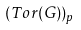<formula> <loc_0><loc_0><loc_500><loc_500>( T o r ( G ) ) _ { p }</formula> 